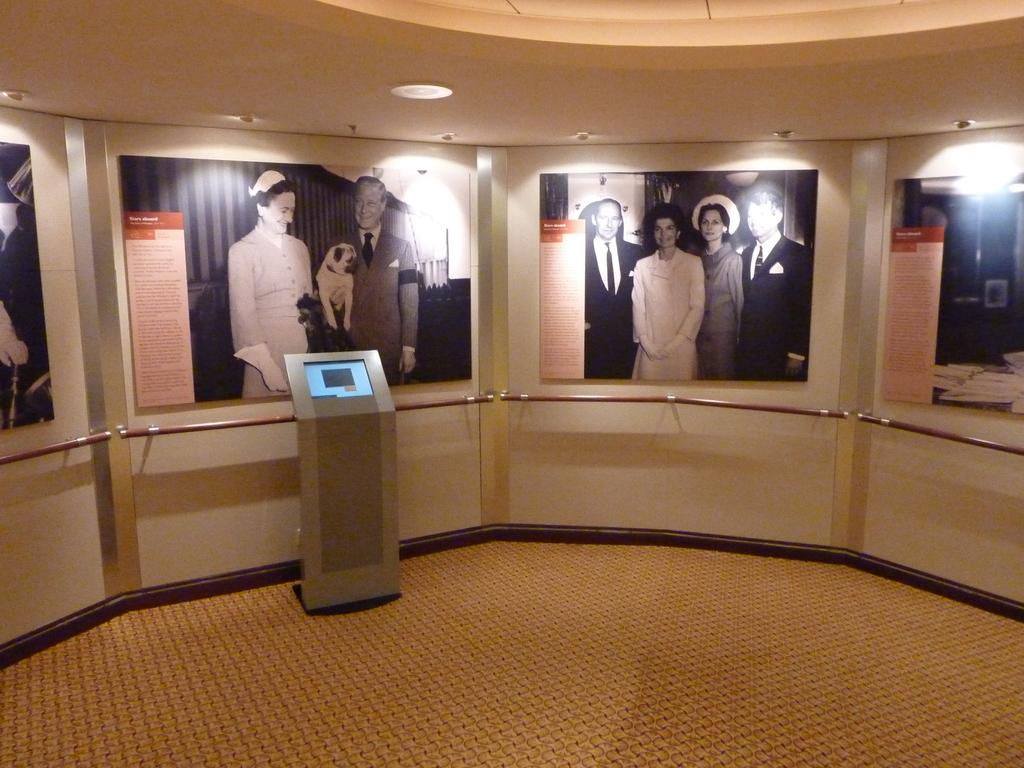What is hanging on the wall in the room? There are photo posters on the wall in the room. What is placed in front of one of the posters? There is a machine in front of one of the posters. What is placed in front of each poster? There are rods kept in front of each poster. What type of sleet can be seen falling on the posters in the image? There is no sleet present in the image; it is an indoor setting with photo posters on the wall. 